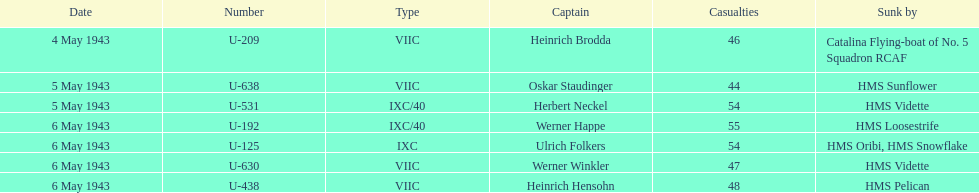Which u-boat was the first to submerge? U-209. 